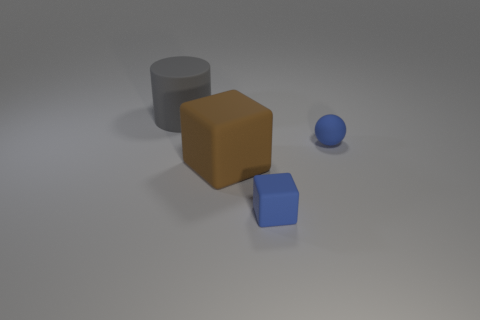What materials do the objects in the image seem to be made of? The objects appear to be made of different materials. The larger grey cylinder and the small blue sphere seem to have a smooth, likely metallic surface, while the brown cube has a matte, possibly wooden texture. The blue cube looks to have a matte finish as well, suggesting a rubbery material. 